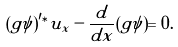Convert formula to latex. <formula><loc_0><loc_0><loc_500><loc_500>( g \psi ) ^ { \prime \ast } u _ { x } - \frac { d } { d x } ( g \psi ) = 0 .</formula> 